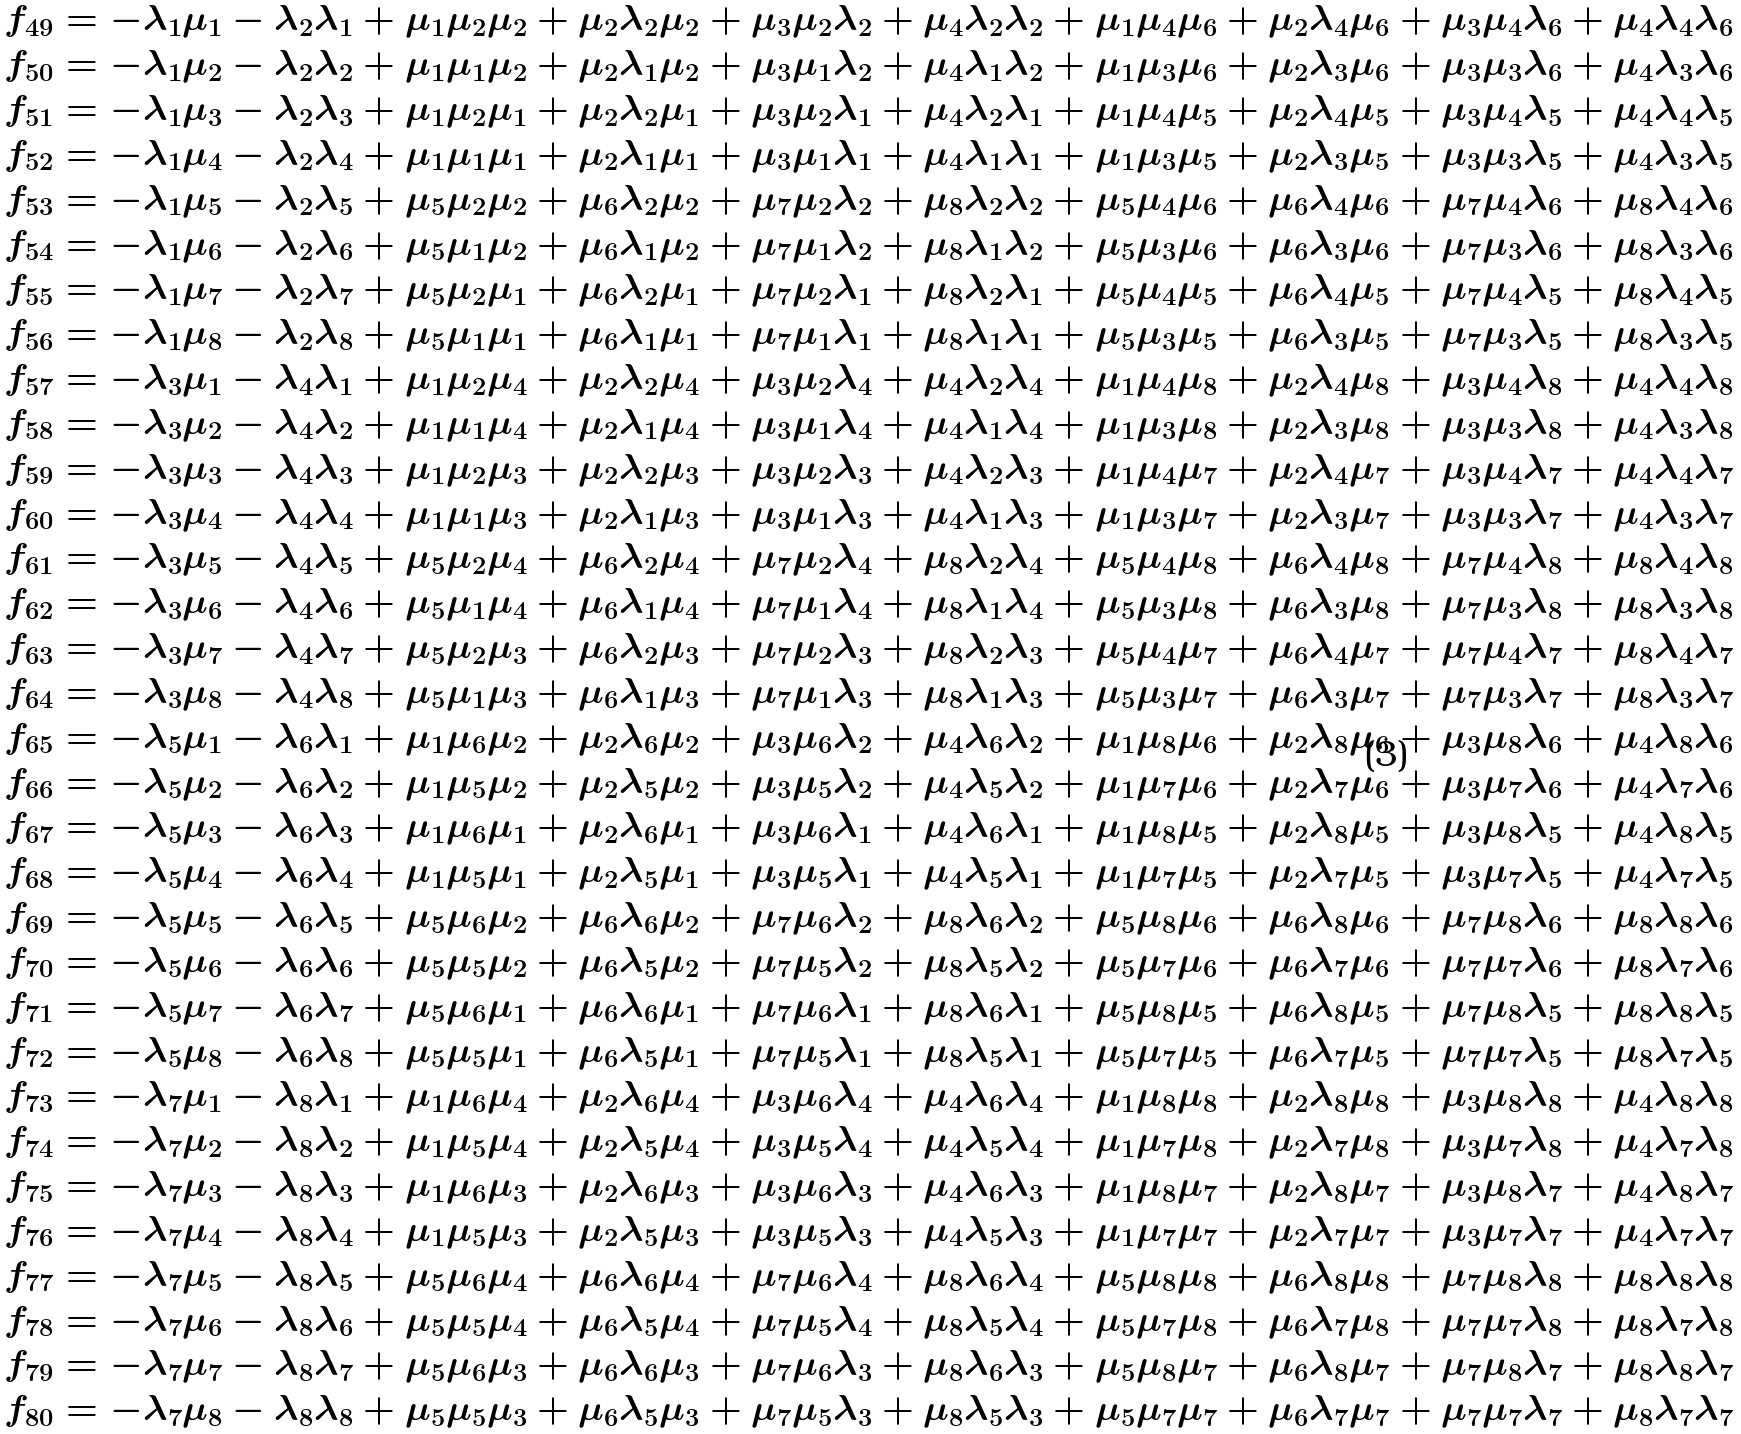Convert formula to latex. <formula><loc_0><loc_0><loc_500><loc_500>f _ { 4 9 } & = - \lambda _ { 1 } \mu _ { 1 } - \lambda _ { 2 } \lambda _ { 1 } + \mu _ { 1 } \mu _ { 2 } \mu _ { 2 } + \mu _ { 2 } \lambda _ { 2 } \mu _ { 2 } + \mu _ { 3 } \mu _ { 2 } \lambda _ { 2 } + \mu _ { 4 } \lambda _ { 2 } \lambda _ { 2 } + \mu _ { 1 } \mu _ { 4 } \mu _ { 6 } + \mu _ { 2 } \lambda _ { 4 } \mu _ { 6 } + \mu _ { 3 } \mu _ { 4 } \lambda _ { 6 } + \mu _ { 4 } \lambda _ { 4 } \lambda _ { 6 } \\ f _ { 5 0 } & = - \lambda _ { 1 } \mu _ { 2 } - \lambda _ { 2 } \lambda _ { 2 } + \mu _ { 1 } \mu _ { 1 } \mu _ { 2 } + \mu _ { 2 } \lambda _ { 1 } \mu _ { 2 } + \mu _ { 3 } \mu _ { 1 } \lambda _ { 2 } + \mu _ { 4 } \lambda _ { 1 } \lambda _ { 2 } + \mu _ { 1 } \mu _ { 3 } \mu _ { 6 } + \mu _ { 2 } \lambda _ { 3 } \mu _ { 6 } + \mu _ { 3 } \mu _ { 3 } \lambda _ { 6 } + \mu _ { 4 } \lambda _ { 3 } \lambda _ { 6 } \\ f _ { 5 1 } & = - \lambda _ { 1 } \mu _ { 3 } - \lambda _ { 2 } \lambda _ { 3 } + \mu _ { 1 } \mu _ { 2 } \mu _ { 1 } + \mu _ { 2 } \lambda _ { 2 } \mu _ { 1 } + \mu _ { 3 } \mu _ { 2 } \lambda _ { 1 } + \mu _ { 4 } \lambda _ { 2 } \lambda _ { 1 } + \mu _ { 1 } \mu _ { 4 } \mu _ { 5 } + \mu _ { 2 } \lambda _ { 4 } \mu _ { 5 } + \mu _ { 3 } \mu _ { 4 } \lambda _ { 5 } + \mu _ { 4 } \lambda _ { 4 } \lambda _ { 5 } \\ f _ { 5 2 } & = - \lambda _ { 1 } \mu _ { 4 } - \lambda _ { 2 } \lambda _ { 4 } + \mu _ { 1 } \mu _ { 1 } \mu _ { 1 } + \mu _ { 2 } \lambda _ { 1 } \mu _ { 1 } + \mu _ { 3 } \mu _ { 1 } \lambda _ { 1 } + \mu _ { 4 } \lambda _ { 1 } \lambda _ { 1 } + \mu _ { 1 } \mu _ { 3 } \mu _ { 5 } + \mu _ { 2 } \lambda _ { 3 } \mu _ { 5 } + \mu _ { 3 } \mu _ { 3 } \lambda _ { 5 } + \mu _ { 4 } \lambda _ { 3 } \lambda _ { 5 } \\ f _ { 5 3 } & = - \lambda _ { 1 } \mu _ { 5 } - \lambda _ { 2 } \lambda _ { 5 } + \mu _ { 5 } \mu _ { 2 } \mu _ { 2 } + \mu _ { 6 } \lambda _ { 2 } \mu _ { 2 } + \mu _ { 7 } \mu _ { 2 } \lambda _ { 2 } + \mu _ { 8 } \lambda _ { 2 } \lambda _ { 2 } + \mu _ { 5 } \mu _ { 4 } \mu _ { 6 } + \mu _ { 6 } \lambda _ { 4 } \mu _ { 6 } + \mu _ { 7 } \mu _ { 4 } \lambda _ { 6 } + \mu _ { 8 } \lambda _ { 4 } \lambda _ { 6 } \\ f _ { 5 4 } & = - \lambda _ { 1 } \mu _ { 6 } - \lambda _ { 2 } \lambda _ { 6 } + \mu _ { 5 } \mu _ { 1 } \mu _ { 2 } + \mu _ { 6 } \lambda _ { 1 } \mu _ { 2 } + \mu _ { 7 } \mu _ { 1 } \lambda _ { 2 } + \mu _ { 8 } \lambda _ { 1 } \lambda _ { 2 } + \mu _ { 5 } \mu _ { 3 } \mu _ { 6 } + \mu _ { 6 } \lambda _ { 3 } \mu _ { 6 } + \mu _ { 7 } \mu _ { 3 } \lambda _ { 6 } + \mu _ { 8 } \lambda _ { 3 } \lambda _ { 6 } \\ f _ { 5 5 } & = - \lambda _ { 1 } \mu _ { 7 } - \lambda _ { 2 } \lambda _ { 7 } + \mu _ { 5 } \mu _ { 2 } \mu _ { 1 } + \mu _ { 6 } \lambda _ { 2 } \mu _ { 1 } + \mu _ { 7 } \mu _ { 2 } \lambda _ { 1 } + \mu _ { 8 } \lambda _ { 2 } \lambda _ { 1 } + \mu _ { 5 } \mu _ { 4 } \mu _ { 5 } + \mu _ { 6 } \lambda _ { 4 } \mu _ { 5 } + \mu _ { 7 } \mu _ { 4 } \lambda _ { 5 } + \mu _ { 8 } \lambda _ { 4 } \lambda _ { 5 } \\ f _ { 5 6 } & = - \lambda _ { 1 } \mu _ { 8 } - \lambda _ { 2 } \lambda _ { 8 } + \mu _ { 5 } \mu _ { 1 } \mu _ { 1 } + \mu _ { 6 } \lambda _ { 1 } \mu _ { 1 } + \mu _ { 7 } \mu _ { 1 } \lambda _ { 1 } + \mu _ { 8 } \lambda _ { 1 } \lambda _ { 1 } + \mu _ { 5 } \mu _ { 3 } \mu _ { 5 } + \mu _ { 6 } \lambda _ { 3 } \mu _ { 5 } + \mu _ { 7 } \mu _ { 3 } \lambda _ { 5 } + \mu _ { 8 } \lambda _ { 3 } \lambda _ { 5 } \\ f _ { 5 7 } & = - \lambda _ { 3 } \mu _ { 1 } - \lambda _ { 4 } \lambda _ { 1 } + \mu _ { 1 } \mu _ { 2 } \mu _ { 4 } + \mu _ { 2 } \lambda _ { 2 } \mu _ { 4 } + \mu _ { 3 } \mu _ { 2 } \lambda _ { 4 } + \mu _ { 4 } \lambda _ { 2 } \lambda _ { 4 } + \mu _ { 1 } \mu _ { 4 } \mu _ { 8 } + \mu _ { 2 } \lambda _ { 4 } \mu _ { 8 } + \mu _ { 3 } \mu _ { 4 } \lambda _ { 8 } + \mu _ { 4 } \lambda _ { 4 } \lambda _ { 8 } \\ f _ { 5 8 } & = - \lambda _ { 3 } \mu _ { 2 } - \lambda _ { 4 } \lambda _ { 2 } + \mu _ { 1 } \mu _ { 1 } \mu _ { 4 } + \mu _ { 2 } \lambda _ { 1 } \mu _ { 4 } + \mu _ { 3 } \mu _ { 1 } \lambda _ { 4 } + \mu _ { 4 } \lambda _ { 1 } \lambda _ { 4 } + \mu _ { 1 } \mu _ { 3 } \mu _ { 8 } + \mu _ { 2 } \lambda _ { 3 } \mu _ { 8 } + \mu _ { 3 } \mu _ { 3 } \lambda _ { 8 } + \mu _ { 4 } \lambda _ { 3 } \lambda _ { 8 } \\ f _ { 5 9 } & = - \lambda _ { 3 } \mu _ { 3 } - \lambda _ { 4 } \lambda _ { 3 } + \mu _ { 1 } \mu _ { 2 } \mu _ { 3 } + \mu _ { 2 } \lambda _ { 2 } \mu _ { 3 } + \mu _ { 3 } \mu _ { 2 } \lambda _ { 3 } + \mu _ { 4 } \lambda _ { 2 } \lambda _ { 3 } + \mu _ { 1 } \mu _ { 4 } \mu _ { 7 } + \mu _ { 2 } \lambda _ { 4 } \mu _ { 7 } + \mu _ { 3 } \mu _ { 4 } \lambda _ { 7 } + \mu _ { 4 } \lambda _ { 4 } \lambda _ { 7 } \\ f _ { 6 0 } & = - \lambda _ { 3 } \mu _ { 4 } - \lambda _ { 4 } \lambda _ { 4 } + \mu _ { 1 } \mu _ { 1 } \mu _ { 3 } + \mu _ { 2 } \lambda _ { 1 } \mu _ { 3 } + \mu _ { 3 } \mu _ { 1 } \lambda _ { 3 } + \mu _ { 4 } \lambda _ { 1 } \lambda _ { 3 } + \mu _ { 1 } \mu _ { 3 } \mu _ { 7 } + \mu _ { 2 } \lambda _ { 3 } \mu _ { 7 } + \mu _ { 3 } \mu _ { 3 } \lambda _ { 7 } + \mu _ { 4 } \lambda _ { 3 } \lambda _ { 7 } \\ f _ { 6 1 } & = - \lambda _ { 3 } \mu _ { 5 } - \lambda _ { 4 } \lambda _ { 5 } + \mu _ { 5 } \mu _ { 2 } \mu _ { 4 } + \mu _ { 6 } \lambda _ { 2 } \mu _ { 4 } + \mu _ { 7 } \mu _ { 2 } \lambda _ { 4 } + \mu _ { 8 } \lambda _ { 2 } \lambda _ { 4 } + \mu _ { 5 } \mu _ { 4 } \mu _ { 8 } + \mu _ { 6 } \lambda _ { 4 } \mu _ { 8 } + \mu _ { 7 } \mu _ { 4 } \lambda _ { 8 } + \mu _ { 8 } \lambda _ { 4 } \lambda _ { 8 } \\ f _ { 6 2 } & = - \lambda _ { 3 } \mu _ { 6 } - \lambda _ { 4 } \lambda _ { 6 } + \mu _ { 5 } \mu _ { 1 } \mu _ { 4 } + \mu _ { 6 } \lambda _ { 1 } \mu _ { 4 } + \mu _ { 7 } \mu _ { 1 } \lambda _ { 4 } + \mu _ { 8 } \lambda _ { 1 } \lambda _ { 4 } + \mu _ { 5 } \mu _ { 3 } \mu _ { 8 } + \mu _ { 6 } \lambda _ { 3 } \mu _ { 8 } + \mu _ { 7 } \mu _ { 3 } \lambda _ { 8 } + \mu _ { 8 } \lambda _ { 3 } \lambda _ { 8 } \\ f _ { 6 3 } & = - \lambda _ { 3 } \mu _ { 7 } - \lambda _ { 4 } \lambda _ { 7 } + \mu _ { 5 } \mu _ { 2 } \mu _ { 3 } + \mu _ { 6 } \lambda _ { 2 } \mu _ { 3 } + \mu _ { 7 } \mu _ { 2 } \lambda _ { 3 } + \mu _ { 8 } \lambda _ { 2 } \lambda _ { 3 } + \mu _ { 5 } \mu _ { 4 } \mu _ { 7 } + \mu _ { 6 } \lambda _ { 4 } \mu _ { 7 } + \mu _ { 7 } \mu _ { 4 } \lambda _ { 7 } + \mu _ { 8 } \lambda _ { 4 } \lambda _ { 7 } \\ f _ { 6 4 } & = - \lambda _ { 3 } \mu _ { 8 } - \lambda _ { 4 } \lambda _ { 8 } + \mu _ { 5 } \mu _ { 1 } \mu _ { 3 } + \mu _ { 6 } \lambda _ { 1 } \mu _ { 3 } + \mu _ { 7 } \mu _ { 1 } \lambda _ { 3 } + \mu _ { 8 } \lambda _ { 1 } \lambda _ { 3 } + \mu _ { 5 } \mu _ { 3 } \mu _ { 7 } + \mu _ { 6 } \lambda _ { 3 } \mu _ { 7 } + \mu _ { 7 } \mu _ { 3 } \lambda _ { 7 } + \mu _ { 8 } \lambda _ { 3 } \lambda _ { 7 } \\ f _ { 6 5 } & = - \lambda _ { 5 } \mu _ { 1 } - \lambda _ { 6 } \lambda _ { 1 } + \mu _ { 1 } \mu _ { 6 } \mu _ { 2 } + \mu _ { 2 } \lambda _ { 6 } \mu _ { 2 } + \mu _ { 3 } \mu _ { 6 } \lambda _ { 2 } + \mu _ { 4 } \lambda _ { 6 } \lambda _ { 2 } + \mu _ { 1 } \mu _ { 8 } \mu _ { 6 } + \mu _ { 2 } \lambda _ { 8 } \mu _ { 6 } + \mu _ { 3 } \mu _ { 8 } \lambda _ { 6 } + \mu _ { 4 } \lambda _ { 8 } \lambda _ { 6 } \\ f _ { 6 6 } & = - \lambda _ { 5 } \mu _ { 2 } - \lambda _ { 6 } \lambda _ { 2 } + \mu _ { 1 } \mu _ { 5 } \mu _ { 2 } + \mu _ { 2 } \lambda _ { 5 } \mu _ { 2 } + \mu _ { 3 } \mu _ { 5 } \lambda _ { 2 } + \mu _ { 4 } \lambda _ { 5 } \lambda _ { 2 } + \mu _ { 1 } \mu _ { 7 } \mu _ { 6 } + \mu _ { 2 } \lambda _ { 7 } \mu _ { 6 } + \mu _ { 3 } \mu _ { 7 } \lambda _ { 6 } + \mu _ { 4 } \lambda _ { 7 } \lambda _ { 6 } \\ f _ { 6 7 } & = - \lambda _ { 5 } \mu _ { 3 } - \lambda _ { 6 } \lambda _ { 3 } + \mu _ { 1 } \mu _ { 6 } \mu _ { 1 } + \mu _ { 2 } \lambda _ { 6 } \mu _ { 1 } + \mu _ { 3 } \mu _ { 6 } \lambda _ { 1 } + \mu _ { 4 } \lambda _ { 6 } \lambda _ { 1 } + \mu _ { 1 } \mu _ { 8 } \mu _ { 5 } + \mu _ { 2 } \lambda _ { 8 } \mu _ { 5 } + \mu _ { 3 } \mu _ { 8 } \lambda _ { 5 } + \mu _ { 4 } \lambda _ { 8 } \lambda _ { 5 } \\ f _ { 6 8 } & = - \lambda _ { 5 } \mu _ { 4 } - \lambda _ { 6 } \lambda _ { 4 } + \mu _ { 1 } \mu _ { 5 } \mu _ { 1 } + \mu _ { 2 } \lambda _ { 5 } \mu _ { 1 } + \mu _ { 3 } \mu _ { 5 } \lambda _ { 1 } + \mu _ { 4 } \lambda _ { 5 } \lambda _ { 1 } + \mu _ { 1 } \mu _ { 7 } \mu _ { 5 } + \mu _ { 2 } \lambda _ { 7 } \mu _ { 5 } + \mu _ { 3 } \mu _ { 7 } \lambda _ { 5 } + \mu _ { 4 } \lambda _ { 7 } \lambda _ { 5 } \\ f _ { 6 9 } & = - \lambda _ { 5 } \mu _ { 5 } - \lambda _ { 6 } \lambda _ { 5 } + \mu _ { 5 } \mu _ { 6 } \mu _ { 2 } + \mu _ { 6 } \lambda _ { 6 } \mu _ { 2 } + \mu _ { 7 } \mu _ { 6 } \lambda _ { 2 } + \mu _ { 8 } \lambda _ { 6 } \lambda _ { 2 } + \mu _ { 5 } \mu _ { 8 } \mu _ { 6 } + \mu _ { 6 } \lambda _ { 8 } \mu _ { 6 } + \mu _ { 7 } \mu _ { 8 } \lambda _ { 6 } + \mu _ { 8 } \lambda _ { 8 } \lambda _ { 6 } \\ f _ { 7 0 } & = - \lambda _ { 5 } \mu _ { 6 } - \lambda _ { 6 } \lambda _ { 6 } + \mu _ { 5 } \mu _ { 5 } \mu _ { 2 } + \mu _ { 6 } \lambda _ { 5 } \mu _ { 2 } + \mu _ { 7 } \mu _ { 5 } \lambda _ { 2 } + \mu _ { 8 } \lambda _ { 5 } \lambda _ { 2 } + \mu _ { 5 } \mu _ { 7 } \mu _ { 6 } + \mu _ { 6 } \lambda _ { 7 } \mu _ { 6 } + \mu _ { 7 } \mu _ { 7 } \lambda _ { 6 } + \mu _ { 8 } \lambda _ { 7 } \lambda _ { 6 } \\ f _ { 7 1 } & = - \lambda _ { 5 } \mu _ { 7 } - \lambda _ { 6 } \lambda _ { 7 } + \mu _ { 5 } \mu _ { 6 } \mu _ { 1 } + \mu _ { 6 } \lambda _ { 6 } \mu _ { 1 } + \mu _ { 7 } \mu _ { 6 } \lambda _ { 1 } + \mu _ { 8 } \lambda _ { 6 } \lambda _ { 1 } + \mu _ { 5 } \mu _ { 8 } \mu _ { 5 } + \mu _ { 6 } \lambda _ { 8 } \mu _ { 5 } + \mu _ { 7 } \mu _ { 8 } \lambda _ { 5 } + \mu _ { 8 } \lambda _ { 8 } \lambda _ { 5 } \\ f _ { 7 2 } & = - \lambda _ { 5 } \mu _ { 8 } - \lambda _ { 6 } \lambda _ { 8 } + \mu _ { 5 } \mu _ { 5 } \mu _ { 1 } + \mu _ { 6 } \lambda _ { 5 } \mu _ { 1 } + \mu _ { 7 } \mu _ { 5 } \lambda _ { 1 } + \mu _ { 8 } \lambda _ { 5 } \lambda _ { 1 } + \mu _ { 5 } \mu _ { 7 } \mu _ { 5 } + \mu _ { 6 } \lambda _ { 7 } \mu _ { 5 } + \mu _ { 7 } \mu _ { 7 } \lambda _ { 5 } + \mu _ { 8 } \lambda _ { 7 } \lambda _ { 5 } \\ f _ { 7 3 } & = - \lambda _ { 7 } \mu _ { 1 } - \lambda _ { 8 } \lambda _ { 1 } + \mu _ { 1 } \mu _ { 6 } \mu _ { 4 } + \mu _ { 2 } \lambda _ { 6 } \mu _ { 4 } + \mu _ { 3 } \mu _ { 6 } \lambda _ { 4 } + \mu _ { 4 } \lambda _ { 6 } \lambda _ { 4 } + \mu _ { 1 } \mu _ { 8 } \mu _ { 8 } + \mu _ { 2 } \lambda _ { 8 } \mu _ { 8 } + \mu _ { 3 } \mu _ { 8 } \lambda _ { 8 } + \mu _ { 4 } \lambda _ { 8 } \lambda _ { 8 } \\ f _ { 7 4 } & = - \lambda _ { 7 } \mu _ { 2 } - \lambda _ { 8 } \lambda _ { 2 } + \mu _ { 1 } \mu _ { 5 } \mu _ { 4 } + \mu _ { 2 } \lambda _ { 5 } \mu _ { 4 } + \mu _ { 3 } \mu _ { 5 } \lambda _ { 4 } + \mu _ { 4 } \lambda _ { 5 } \lambda _ { 4 } + \mu _ { 1 } \mu _ { 7 } \mu _ { 8 } + \mu _ { 2 } \lambda _ { 7 } \mu _ { 8 } + \mu _ { 3 } \mu _ { 7 } \lambda _ { 8 } + \mu _ { 4 } \lambda _ { 7 } \lambda _ { 8 } \\ f _ { 7 5 } & = - \lambda _ { 7 } \mu _ { 3 } - \lambda _ { 8 } \lambda _ { 3 } + \mu _ { 1 } \mu _ { 6 } \mu _ { 3 } + \mu _ { 2 } \lambda _ { 6 } \mu _ { 3 } + \mu _ { 3 } \mu _ { 6 } \lambda _ { 3 } + \mu _ { 4 } \lambda _ { 6 } \lambda _ { 3 } + \mu _ { 1 } \mu _ { 8 } \mu _ { 7 } + \mu _ { 2 } \lambda _ { 8 } \mu _ { 7 } + \mu _ { 3 } \mu _ { 8 } \lambda _ { 7 } + \mu _ { 4 } \lambda _ { 8 } \lambda _ { 7 } \\ f _ { 7 6 } & = - \lambda _ { 7 } \mu _ { 4 } - \lambda _ { 8 } \lambda _ { 4 } + \mu _ { 1 } \mu _ { 5 } \mu _ { 3 } + \mu _ { 2 } \lambda _ { 5 } \mu _ { 3 } + \mu _ { 3 } \mu _ { 5 } \lambda _ { 3 } + \mu _ { 4 } \lambda _ { 5 } \lambda _ { 3 } + \mu _ { 1 } \mu _ { 7 } \mu _ { 7 } + \mu _ { 2 } \lambda _ { 7 } \mu _ { 7 } + \mu _ { 3 } \mu _ { 7 } \lambda _ { 7 } + \mu _ { 4 } \lambda _ { 7 } \lambda _ { 7 } \\ f _ { 7 7 } & = - \lambda _ { 7 } \mu _ { 5 } - \lambda _ { 8 } \lambda _ { 5 } + \mu _ { 5 } \mu _ { 6 } \mu _ { 4 } + \mu _ { 6 } \lambda _ { 6 } \mu _ { 4 } + \mu _ { 7 } \mu _ { 6 } \lambda _ { 4 } + \mu _ { 8 } \lambda _ { 6 } \lambda _ { 4 } + \mu _ { 5 } \mu _ { 8 } \mu _ { 8 } + \mu _ { 6 } \lambda _ { 8 } \mu _ { 8 } + \mu _ { 7 } \mu _ { 8 } \lambda _ { 8 } + \mu _ { 8 } \lambda _ { 8 } \lambda _ { 8 } \\ f _ { 7 8 } & = - \lambda _ { 7 } \mu _ { 6 } - \lambda _ { 8 } \lambda _ { 6 } + \mu _ { 5 } \mu _ { 5 } \mu _ { 4 } + \mu _ { 6 } \lambda _ { 5 } \mu _ { 4 } + \mu _ { 7 } \mu _ { 5 } \lambda _ { 4 } + \mu _ { 8 } \lambda _ { 5 } \lambda _ { 4 } + \mu _ { 5 } \mu _ { 7 } \mu _ { 8 } + \mu _ { 6 } \lambda _ { 7 } \mu _ { 8 } + \mu _ { 7 } \mu _ { 7 } \lambda _ { 8 } + \mu _ { 8 } \lambda _ { 7 } \lambda _ { 8 } \\ f _ { 7 9 } & = - \lambda _ { 7 } \mu _ { 7 } - \lambda _ { 8 } \lambda _ { 7 } + \mu _ { 5 } \mu _ { 6 } \mu _ { 3 } + \mu _ { 6 } \lambda _ { 6 } \mu _ { 3 } + \mu _ { 7 } \mu _ { 6 } \lambda _ { 3 } + \mu _ { 8 } \lambda _ { 6 } \lambda _ { 3 } + \mu _ { 5 } \mu _ { 8 } \mu _ { 7 } + \mu _ { 6 } \lambda _ { 8 } \mu _ { 7 } + \mu _ { 7 } \mu _ { 8 } \lambda _ { 7 } + \mu _ { 8 } \lambda _ { 8 } \lambda _ { 7 } \\ f _ { 8 0 } & = - \lambda _ { 7 } \mu _ { 8 } - \lambda _ { 8 } \lambda _ { 8 } + \mu _ { 5 } \mu _ { 5 } \mu _ { 3 } + \mu _ { 6 } \lambda _ { 5 } \mu _ { 3 } + \mu _ { 7 } \mu _ { 5 } \lambda _ { 3 } + \mu _ { 8 } \lambda _ { 5 } \lambda _ { 3 } + \mu _ { 5 } \mu _ { 7 } \mu _ { 7 } + \mu _ { 6 } \lambda _ { 7 } \mu _ { 7 } + \mu _ { 7 } \mu _ { 7 } \lambda _ { 7 } + \mu _ { 8 } \lambda _ { 7 } \lambda _ { 7 }</formula> 